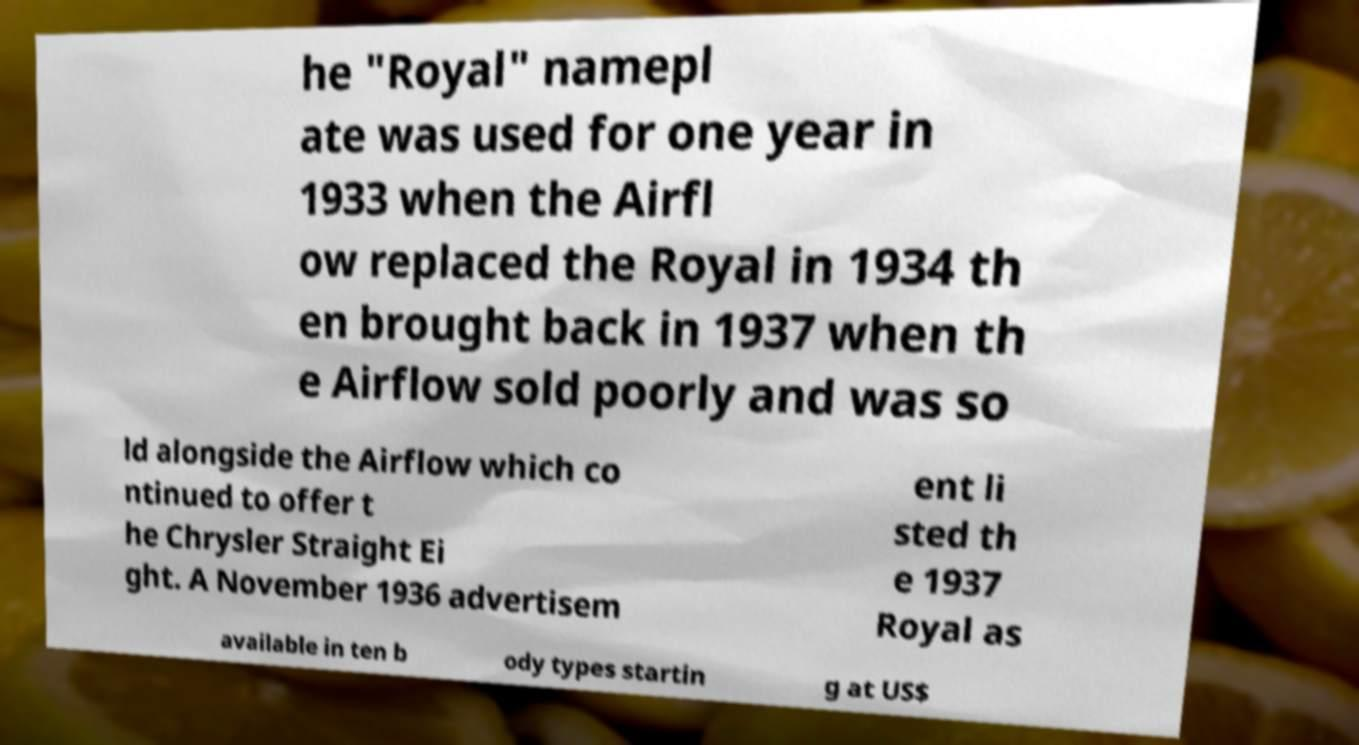Please identify and transcribe the text found in this image. he "Royal" namepl ate was used for one year in 1933 when the Airfl ow replaced the Royal in 1934 th en brought back in 1937 when th e Airflow sold poorly and was so ld alongside the Airflow which co ntinued to offer t he Chrysler Straight Ei ght. A November 1936 advertisem ent li sted th e 1937 Royal as available in ten b ody types startin g at US$ 